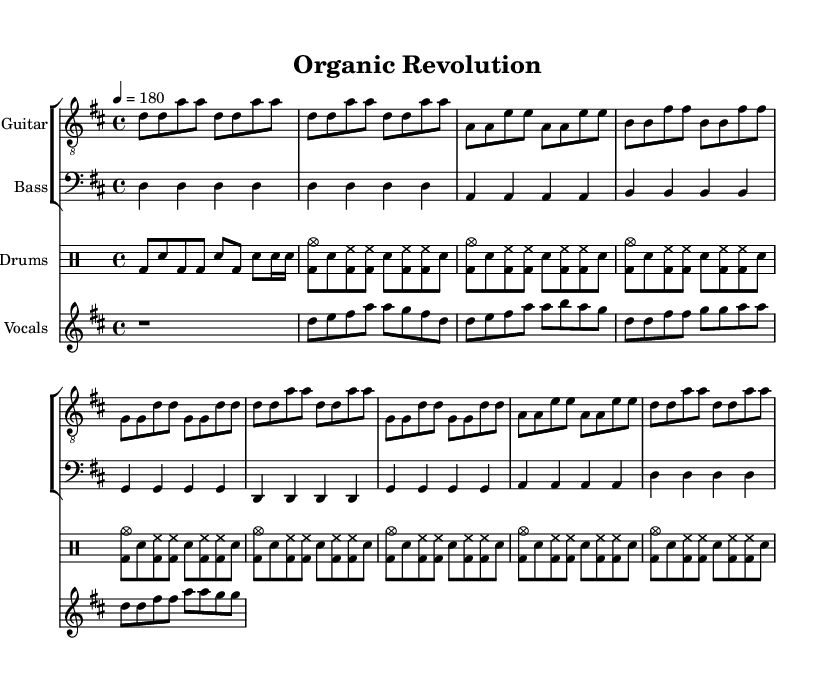What is the time signature of this music? The time signature is indicated at the beginning of the sheet music, which shows that it is in 4/4 time, meaning there are four beats per measure.
Answer: 4/4 What is the tempo of this piece? The tempo marking shows that the piece is set at a speed of 180 beats per minute, indicated by "4 = 180".
Answer: 180 How many verses are present in the structure of the song? The sheet music features a sequence that consists of a verse that repeats multiple times, as noted in the structure of the music, which indicates at least two occurrences of verses.
Answer: 2 What is the primary theme of the lyrics as shown in the sheet music? The lyrics express a connection to sustainable farming practices and indigenous knowledge, reflecting the overarching theme of organic farming and community.
Answer: Sustainability Which instrument is marked to play the "vocals" part? The sheet music explicitly lists a "Vocals" staff, indicating that the vocal melody is written to be sung, contrasting with the instrumental parts.
Answer: Vocals What is the key signature of this music? The key signature is indicated by the number of sharp or flat symbols at the beginning of the staff line, which indicates that it is in D major with two sharps, F# and C#.
Answer: D major What type of punk music is this piece representative of? Given the lyrical content focusing on sustainability and the fast-paced structure typical of punk, this piece can be categorized as eco-punk or political punk, which addresses social issues through its music.
Answer: Eco-punk 